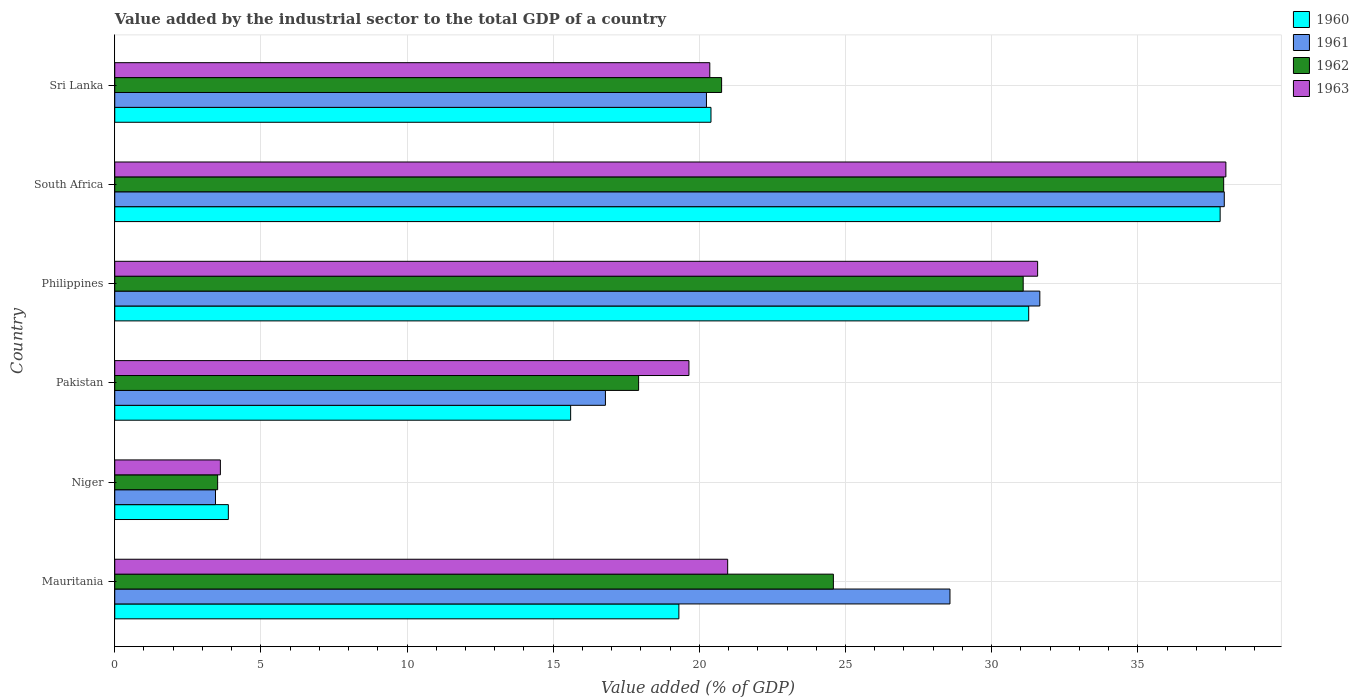Are the number of bars per tick equal to the number of legend labels?
Your response must be concise. Yes. Are the number of bars on each tick of the Y-axis equal?
Provide a succinct answer. Yes. How many bars are there on the 6th tick from the top?
Offer a very short reply. 4. How many bars are there on the 3rd tick from the bottom?
Keep it short and to the point. 4. What is the label of the 5th group of bars from the top?
Your answer should be very brief. Niger. In how many cases, is the number of bars for a given country not equal to the number of legend labels?
Your answer should be compact. 0. What is the value added by the industrial sector to the total GDP in 1963 in Niger?
Your answer should be compact. 3.61. Across all countries, what is the maximum value added by the industrial sector to the total GDP in 1963?
Your answer should be compact. 38.01. Across all countries, what is the minimum value added by the industrial sector to the total GDP in 1963?
Offer a very short reply. 3.61. In which country was the value added by the industrial sector to the total GDP in 1961 maximum?
Offer a terse response. South Africa. In which country was the value added by the industrial sector to the total GDP in 1961 minimum?
Offer a terse response. Niger. What is the total value added by the industrial sector to the total GDP in 1961 in the graph?
Ensure brevity in your answer.  138.66. What is the difference between the value added by the industrial sector to the total GDP in 1960 in Mauritania and that in Sri Lanka?
Provide a short and direct response. -1.1. What is the difference between the value added by the industrial sector to the total GDP in 1961 in Mauritania and the value added by the industrial sector to the total GDP in 1960 in South Africa?
Ensure brevity in your answer.  -9.24. What is the average value added by the industrial sector to the total GDP in 1963 per country?
Make the answer very short. 22.36. What is the difference between the value added by the industrial sector to the total GDP in 1961 and value added by the industrial sector to the total GDP in 1962 in Mauritania?
Offer a very short reply. 3.99. In how many countries, is the value added by the industrial sector to the total GDP in 1963 greater than 27 %?
Your answer should be very brief. 2. What is the ratio of the value added by the industrial sector to the total GDP in 1960 in Pakistan to that in South Africa?
Your answer should be very brief. 0.41. What is the difference between the highest and the second highest value added by the industrial sector to the total GDP in 1963?
Your response must be concise. 6.44. What is the difference between the highest and the lowest value added by the industrial sector to the total GDP in 1963?
Ensure brevity in your answer.  34.4. What does the 2nd bar from the top in Mauritania represents?
Your answer should be compact. 1962. Is it the case that in every country, the sum of the value added by the industrial sector to the total GDP in 1960 and value added by the industrial sector to the total GDP in 1963 is greater than the value added by the industrial sector to the total GDP in 1961?
Your answer should be compact. Yes. How many bars are there?
Your answer should be compact. 24. How many countries are there in the graph?
Provide a short and direct response. 6. Are the values on the major ticks of X-axis written in scientific E-notation?
Ensure brevity in your answer.  No. Where does the legend appear in the graph?
Provide a short and direct response. Top right. How are the legend labels stacked?
Offer a very short reply. Vertical. What is the title of the graph?
Your answer should be compact. Value added by the industrial sector to the total GDP of a country. Does "1978" appear as one of the legend labels in the graph?
Your response must be concise. No. What is the label or title of the X-axis?
Offer a very short reply. Value added (% of GDP). What is the Value added (% of GDP) of 1960 in Mauritania?
Offer a terse response. 19.3. What is the Value added (% of GDP) in 1961 in Mauritania?
Give a very brief answer. 28.57. What is the Value added (% of GDP) of 1962 in Mauritania?
Provide a succinct answer. 24.59. What is the Value added (% of GDP) in 1963 in Mauritania?
Your response must be concise. 20.97. What is the Value added (% of GDP) in 1960 in Niger?
Your answer should be compact. 3.89. What is the Value added (% of GDP) of 1961 in Niger?
Your answer should be compact. 3.45. What is the Value added (% of GDP) of 1962 in Niger?
Offer a very short reply. 3.52. What is the Value added (% of GDP) of 1963 in Niger?
Offer a very short reply. 3.61. What is the Value added (% of GDP) in 1960 in Pakistan?
Offer a terse response. 15.6. What is the Value added (% of GDP) of 1961 in Pakistan?
Give a very brief answer. 16.79. What is the Value added (% of GDP) of 1962 in Pakistan?
Your response must be concise. 17.92. What is the Value added (% of GDP) of 1963 in Pakistan?
Offer a terse response. 19.64. What is the Value added (% of GDP) in 1960 in Philippines?
Keep it short and to the point. 31.27. What is the Value added (% of GDP) of 1961 in Philippines?
Offer a terse response. 31.65. What is the Value added (% of GDP) in 1962 in Philippines?
Make the answer very short. 31.08. What is the Value added (% of GDP) of 1963 in Philippines?
Your response must be concise. 31.57. What is the Value added (% of GDP) of 1960 in South Africa?
Offer a terse response. 37.82. What is the Value added (% of GDP) in 1961 in South Africa?
Your response must be concise. 37.96. What is the Value added (% of GDP) of 1962 in South Africa?
Offer a very short reply. 37.94. What is the Value added (% of GDP) of 1963 in South Africa?
Give a very brief answer. 38.01. What is the Value added (% of GDP) in 1960 in Sri Lanka?
Ensure brevity in your answer.  20.4. What is the Value added (% of GDP) of 1961 in Sri Lanka?
Your answer should be very brief. 20.24. What is the Value added (% of GDP) in 1962 in Sri Lanka?
Your answer should be very brief. 20.76. What is the Value added (% of GDP) of 1963 in Sri Lanka?
Keep it short and to the point. 20.36. Across all countries, what is the maximum Value added (% of GDP) of 1960?
Provide a short and direct response. 37.82. Across all countries, what is the maximum Value added (% of GDP) in 1961?
Your answer should be very brief. 37.96. Across all countries, what is the maximum Value added (% of GDP) in 1962?
Ensure brevity in your answer.  37.94. Across all countries, what is the maximum Value added (% of GDP) in 1963?
Offer a very short reply. 38.01. Across all countries, what is the minimum Value added (% of GDP) of 1960?
Make the answer very short. 3.89. Across all countries, what is the minimum Value added (% of GDP) of 1961?
Offer a terse response. 3.45. Across all countries, what is the minimum Value added (% of GDP) of 1962?
Make the answer very short. 3.52. Across all countries, what is the minimum Value added (% of GDP) in 1963?
Provide a short and direct response. 3.61. What is the total Value added (% of GDP) in 1960 in the graph?
Give a very brief answer. 128.27. What is the total Value added (% of GDP) of 1961 in the graph?
Keep it short and to the point. 138.66. What is the total Value added (% of GDP) of 1962 in the graph?
Offer a very short reply. 135.81. What is the total Value added (% of GDP) in 1963 in the graph?
Keep it short and to the point. 134.17. What is the difference between the Value added (% of GDP) in 1960 in Mauritania and that in Niger?
Ensure brevity in your answer.  15.41. What is the difference between the Value added (% of GDP) in 1961 in Mauritania and that in Niger?
Offer a very short reply. 25.13. What is the difference between the Value added (% of GDP) in 1962 in Mauritania and that in Niger?
Your answer should be very brief. 21.07. What is the difference between the Value added (% of GDP) in 1963 in Mauritania and that in Niger?
Ensure brevity in your answer.  17.36. What is the difference between the Value added (% of GDP) in 1960 in Mauritania and that in Pakistan?
Provide a short and direct response. 3.7. What is the difference between the Value added (% of GDP) in 1961 in Mauritania and that in Pakistan?
Your answer should be very brief. 11.79. What is the difference between the Value added (% of GDP) in 1962 in Mauritania and that in Pakistan?
Ensure brevity in your answer.  6.66. What is the difference between the Value added (% of GDP) in 1963 in Mauritania and that in Pakistan?
Provide a succinct answer. 1.33. What is the difference between the Value added (% of GDP) of 1960 in Mauritania and that in Philippines?
Your answer should be very brief. -11.97. What is the difference between the Value added (% of GDP) of 1961 in Mauritania and that in Philippines?
Provide a succinct answer. -3.07. What is the difference between the Value added (% of GDP) of 1962 in Mauritania and that in Philippines?
Your answer should be very brief. -6.49. What is the difference between the Value added (% of GDP) in 1963 in Mauritania and that in Philippines?
Offer a terse response. -10.6. What is the difference between the Value added (% of GDP) in 1960 in Mauritania and that in South Africa?
Your answer should be compact. -18.52. What is the difference between the Value added (% of GDP) of 1961 in Mauritania and that in South Africa?
Ensure brevity in your answer.  -9.38. What is the difference between the Value added (% of GDP) of 1962 in Mauritania and that in South Africa?
Offer a terse response. -13.35. What is the difference between the Value added (% of GDP) in 1963 in Mauritania and that in South Africa?
Your answer should be very brief. -17.04. What is the difference between the Value added (% of GDP) of 1960 in Mauritania and that in Sri Lanka?
Your response must be concise. -1.1. What is the difference between the Value added (% of GDP) in 1961 in Mauritania and that in Sri Lanka?
Make the answer very short. 8.33. What is the difference between the Value added (% of GDP) in 1962 in Mauritania and that in Sri Lanka?
Offer a very short reply. 3.82. What is the difference between the Value added (% of GDP) in 1963 in Mauritania and that in Sri Lanka?
Make the answer very short. 0.61. What is the difference between the Value added (% of GDP) of 1960 in Niger and that in Pakistan?
Offer a terse response. -11.71. What is the difference between the Value added (% of GDP) of 1961 in Niger and that in Pakistan?
Offer a very short reply. -13.34. What is the difference between the Value added (% of GDP) of 1962 in Niger and that in Pakistan?
Keep it short and to the point. -14.4. What is the difference between the Value added (% of GDP) in 1963 in Niger and that in Pakistan?
Offer a very short reply. -16.03. What is the difference between the Value added (% of GDP) of 1960 in Niger and that in Philippines?
Offer a terse response. -27.38. What is the difference between the Value added (% of GDP) of 1961 in Niger and that in Philippines?
Your answer should be very brief. -28.2. What is the difference between the Value added (% of GDP) in 1962 in Niger and that in Philippines?
Your response must be concise. -27.56. What is the difference between the Value added (% of GDP) in 1963 in Niger and that in Philippines?
Ensure brevity in your answer.  -27.96. What is the difference between the Value added (% of GDP) of 1960 in Niger and that in South Africa?
Your answer should be very brief. -33.93. What is the difference between the Value added (% of GDP) of 1961 in Niger and that in South Africa?
Provide a short and direct response. -34.51. What is the difference between the Value added (% of GDP) of 1962 in Niger and that in South Africa?
Keep it short and to the point. -34.42. What is the difference between the Value added (% of GDP) of 1963 in Niger and that in South Africa?
Your answer should be very brief. -34.4. What is the difference between the Value added (% of GDP) in 1960 in Niger and that in Sri Lanka?
Your response must be concise. -16.51. What is the difference between the Value added (% of GDP) of 1961 in Niger and that in Sri Lanka?
Ensure brevity in your answer.  -16.8. What is the difference between the Value added (% of GDP) in 1962 in Niger and that in Sri Lanka?
Provide a succinct answer. -17.24. What is the difference between the Value added (% of GDP) in 1963 in Niger and that in Sri Lanka?
Offer a very short reply. -16.74. What is the difference between the Value added (% of GDP) of 1960 in Pakistan and that in Philippines?
Your response must be concise. -15.67. What is the difference between the Value added (% of GDP) of 1961 in Pakistan and that in Philippines?
Your answer should be very brief. -14.86. What is the difference between the Value added (% of GDP) in 1962 in Pakistan and that in Philippines?
Give a very brief answer. -13.16. What is the difference between the Value added (% of GDP) in 1963 in Pakistan and that in Philippines?
Offer a terse response. -11.93. What is the difference between the Value added (% of GDP) of 1960 in Pakistan and that in South Africa?
Ensure brevity in your answer.  -22.22. What is the difference between the Value added (% of GDP) of 1961 in Pakistan and that in South Africa?
Give a very brief answer. -21.17. What is the difference between the Value added (% of GDP) in 1962 in Pakistan and that in South Africa?
Offer a very short reply. -20.02. What is the difference between the Value added (% of GDP) of 1963 in Pakistan and that in South Africa?
Your response must be concise. -18.37. What is the difference between the Value added (% of GDP) in 1960 in Pakistan and that in Sri Lanka?
Provide a short and direct response. -4.8. What is the difference between the Value added (% of GDP) in 1961 in Pakistan and that in Sri Lanka?
Keep it short and to the point. -3.46. What is the difference between the Value added (% of GDP) of 1962 in Pakistan and that in Sri Lanka?
Provide a short and direct response. -2.84. What is the difference between the Value added (% of GDP) of 1963 in Pakistan and that in Sri Lanka?
Provide a succinct answer. -0.71. What is the difference between the Value added (% of GDP) of 1960 in Philippines and that in South Africa?
Offer a terse response. -6.55. What is the difference between the Value added (% of GDP) of 1961 in Philippines and that in South Africa?
Your response must be concise. -6.31. What is the difference between the Value added (% of GDP) in 1962 in Philippines and that in South Africa?
Your answer should be very brief. -6.86. What is the difference between the Value added (% of GDP) of 1963 in Philippines and that in South Africa?
Your response must be concise. -6.44. What is the difference between the Value added (% of GDP) of 1960 in Philippines and that in Sri Lanka?
Make the answer very short. 10.87. What is the difference between the Value added (% of GDP) in 1961 in Philippines and that in Sri Lanka?
Your answer should be compact. 11.41. What is the difference between the Value added (% of GDP) in 1962 in Philippines and that in Sri Lanka?
Provide a succinct answer. 10.32. What is the difference between the Value added (% of GDP) in 1963 in Philippines and that in Sri Lanka?
Ensure brevity in your answer.  11.22. What is the difference between the Value added (% of GDP) in 1960 in South Africa and that in Sri Lanka?
Your response must be concise. 17.42. What is the difference between the Value added (% of GDP) of 1961 in South Africa and that in Sri Lanka?
Offer a terse response. 17.72. What is the difference between the Value added (% of GDP) in 1962 in South Africa and that in Sri Lanka?
Your answer should be very brief. 17.18. What is the difference between the Value added (% of GDP) of 1963 in South Africa and that in Sri Lanka?
Keep it short and to the point. 17.66. What is the difference between the Value added (% of GDP) of 1960 in Mauritania and the Value added (% of GDP) of 1961 in Niger?
Give a very brief answer. 15.85. What is the difference between the Value added (% of GDP) of 1960 in Mauritania and the Value added (% of GDP) of 1962 in Niger?
Your response must be concise. 15.78. What is the difference between the Value added (% of GDP) of 1960 in Mauritania and the Value added (% of GDP) of 1963 in Niger?
Make the answer very short. 15.69. What is the difference between the Value added (% of GDP) in 1961 in Mauritania and the Value added (% of GDP) in 1962 in Niger?
Keep it short and to the point. 25.05. What is the difference between the Value added (% of GDP) of 1961 in Mauritania and the Value added (% of GDP) of 1963 in Niger?
Give a very brief answer. 24.96. What is the difference between the Value added (% of GDP) of 1962 in Mauritania and the Value added (% of GDP) of 1963 in Niger?
Give a very brief answer. 20.97. What is the difference between the Value added (% of GDP) in 1960 in Mauritania and the Value added (% of GDP) in 1961 in Pakistan?
Provide a short and direct response. 2.51. What is the difference between the Value added (% of GDP) of 1960 in Mauritania and the Value added (% of GDP) of 1962 in Pakistan?
Keep it short and to the point. 1.38. What is the difference between the Value added (% of GDP) of 1960 in Mauritania and the Value added (% of GDP) of 1963 in Pakistan?
Keep it short and to the point. -0.34. What is the difference between the Value added (% of GDP) in 1961 in Mauritania and the Value added (% of GDP) in 1962 in Pakistan?
Offer a very short reply. 10.65. What is the difference between the Value added (% of GDP) of 1961 in Mauritania and the Value added (% of GDP) of 1963 in Pakistan?
Keep it short and to the point. 8.93. What is the difference between the Value added (% of GDP) of 1962 in Mauritania and the Value added (% of GDP) of 1963 in Pakistan?
Offer a very short reply. 4.94. What is the difference between the Value added (% of GDP) of 1960 in Mauritania and the Value added (% of GDP) of 1961 in Philippines?
Keep it short and to the point. -12.35. What is the difference between the Value added (% of GDP) in 1960 in Mauritania and the Value added (% of GDP) in 1962 in Philippines?
Your response must be concise. -11.78. What is the difference between the Value added (% of GDP) of 1960 in Mauritania and the Value added (% of GDP) of 1963 in Philippines?
Keep it short and to the point. -12.27. What is the difference between the Value added (% of GDP) of 1961 in Mauritania and the Value added (% of GDP) of 1962 in Philippines?
Give a very brief answer. -2.51. What is the difference between the Value added (% of GDP) in 1961 in Mauritania and the Value added (% of GDP) in 1963 in Philippines?
Give a very brief answer. -3. What is the difference between the Value added (% of GDP) in 1962 in Mauritania and the Value added (% of GDP) in 1963 in Philippines?
Offer a terse response. -6.99. What is the difference between the Value added (% of GDP) of 1960 in Mauritania and the Value added (% of GDP) of 1961 in South Africa?
Make the answer very short. -18.66. What is the difference between the Value added (% of GDP) in 1960 in Mauritania and the Value added (% of GDP) in 1962 in South Africa?
Offer a terse response. -18.64. What is the difference between the Value added (% of GDP) of 1960 in Mauritania and the Value added (% of GDP) of 1963 in South Africa?
Keep it short and to the point. -18.71. What is the difference between the Value added (% of GDP) of 1961 in Mauritania and the Value added (% of GDP) of 1962 in South Africa?
Keep it short and to the point. -9.36. What is the difference between the Value added (% of GDP) of 1961 in Mauritania and the Value added (% of GDP) of 1963 in South Africa?
Provide a succinct answer. -9.44. What is the difference between the Value added (% of GDP) of 1962 in Mauritania and the Value added (% of GDP) of 1963 in South Africa?
Provide a succinct answer. -13.43. What is the difference between the Value added (% of GDP) in 1960 in Mauritania and the Value added (% of GDP) in 1961 in Sri Lanka?
Your response must be concise. -0.94. What is the difference between the Value added (% of GDP) of 1960 in Mauritania and the Value added (% of GDP) of 1962 in Sri Lanka?
Provide a succinct answer. -1.46. What is the difference between the Value added (% of GDP) of 1960 in Mauritania and the Value added (% of GDP) of 1963 in Sri Lanka?
Provide a short and direct response. -1.06. What is the difference between the Value added (% of GDP) of 1961 in Mauritania and the Value added (% of GDP) of 1962 in Sri Lanka?
Provide a short and direct response. 7.81. What is the difference between the Value added (% of GDP) in 1961 in Mauritania and the Value added (% of GDP) in 1963 in Sri Lanka?
Provide a succinct answer. 8.22. What is the difference between the Value added (% of GDP) in 1962 in Mauritania and the Value added (% of GDP) in 1963 in Sri Lanka?
Offer a terse response. 4.23. What is the difference between the Value added (% of GDP) in 1960 in Niger and the Value added (% of GDP) in 1961 in Pakistan?
Give a very brief answer. -12.9. What is the difference between the Value added (% of GDP) of 1960 in Niger and the Value added (% of GDP) of 1962 in Pakistan?
Offer a very short reply. -14.04. What is the difference between the Value added (% of GDP) of 1960 in Niger and the Value added (% of GDP) of 1963 in Pakistan?
Provide a short and direct response. -15.76. What is the difference between the Value added (% of GDP) of 1961 in Niger and the Value added (% of GDP) of 1962 in Pakistan?
Ensure brevity in your answer.  -14.48. What is the difference between the Value added (% of GDP) of 1961 in Niger and the Value added (% of GDP) of 1963 in Pakistan?
Offer a very short reply. -16.2. What is the difference between the Value added (% of GDP) of 1962 in Niger and the Value added (% of GDP) of 1963 in Pakistan?
Provide a short and direct response. -16.12. What is the difference between the Value added (% of GDP) in 1960 in Niger and the Value added (% of GDP) in 1961 in Philippines?
Your answer should be compact. -27.76. What is the difference between the Value added (% of GDP) in 1960 in Niger and the Value added (% of GDP) in 1962 in Philippines?
Provide a short and direct response. -27.19. What is the difference between the Value added (% of GDP) in 1960 in Niger and the Value added (% of GDP) in 1963 in Philippines?
Provide a short and direct response. -27.69. What is the difference between the Value added (% of GDP) in 1961 in Niger and the Value added (% of GDP) in 1962 in Philippines?
Ensure brevity in your answer.  -27.63. What is the difference between the Value added (% of GDP) in 1961 in Niger and the Value added (% of GDP) in 1963 in Philippines?
Ensure brevity in your answer.  -28.13. What is the difference between the Value added (% of GDP) of 1962 in Niger and the Value added (% of GDP) of 1963 in Philippines?
Your answer should be very brief. -28.05. What is the difference between the Value added (% of GDP) of 1960 in Niger and the Value added (% of GDP) of 1961 in South Africa?
Your response must be concise. -34.07. What is the difference between the Value added (% of GDP) in 1960 in Niger and the Value added (% of GDP) in 1962 in South Africa?
Give a very brief answer. -34.05. What is the difference between the Value added (% of GDP) of 1960 in Niger and the Value added (% of GDP) of 1963 in South Africa?
Your answer should be compact. -34.13. What is the difference between the Value added (% of GDP) of 1961 in Niger and the Value added (% of GDP) of 1962 in South Africa?
Offer a very short reply. -34.49. What is the difference between the Value added (% of GDP) of 1961 in Niger and the Value added (% of GDP) of 1963 in South Africa?
Keep it short and to the point. -34.57. What is the difference between the Value added (% of GDP) in 1962 in Niger and the Value added (% of GDP) in 1963 in South Africa?
Keep it short and to the point. -34.49. What is the difference between the Value added (% of GDP) in 1960 in Niger and the Value added (% of GDP) in 1961 in Sri Lanka?
Keep it short and to the point. -16.36. What is the difference between the Value added (% of GDP) of 1960 in Niger and the Value added (% of GDP) of 1962 in Sri Lanka?
Offer a terse response. -16.88. What is the difference between the Value added (% of GDP) of 1960 in Niger and the Value added (% of GDP) of 1963 in Sri Lanka?
Ensure brevity in your answer.  -16.47. What is the difference between the Value added (% of GDP) in 1961 in Niger and the Value added (% of GDP) in 1962 in Sri Lanka?
Your answer should be compact. -17.32. What is the difference between the Value added (% of GDP) of 1961 in Niger and the Value added (% of GDP) of 1963 in Sri Lanka?
Offer a very short reply. -16.91. What is the difference between the Value added (% of GDP) of 1962 in Niger and the Value added (% of GDP) of 1963 in Sri Lanka?
Ensure brevity in your answer.  -16.84. What is the difference between the Value added (% of GDP) in 1960 in Pakistan and the Value added (% of GDP) in 1961 in Philippines?
Keep it short and to the point. -16.05. What is the difference between the Value added (% of GDP) of 1960 in Pakistan and the Value added (% of GDP) of 1962 in Philippines?
Give a very brief answer. -15.48. What is the difference between the Value added (% of GDP) of 1960 in Pakistan and the Value added (% of GDP) of 1963 in Philippines?
Your response must be concise. -15.98. What is the difference between the Value added (% of GDP) in 1961 in Pakistan and the Value added (% of GDP) in 1962 in Philippines?
Offer a terse response. -14.29. What is the difference between the Value added (% of GDP) in 1961 in Pakistan and the Value added (% of GDP) in 1963 in Philippines?
Ensure brevity in your answer.  -14.79. What is the difference between the Value added (% of GDP) of 1962 in Pakistan and the Value added (% of GDP) of 1963 in Philippines?
Offer a terse response. -13.65. What is the difference between the Value added (% of GDP) of 1960 in Pakistan and the Value added (% of GDP) of 1961 in South Africa?
Your answer should be very brief. -22.36. What is the difference between the Value added (% of GDP) of 1960 in Pakistan and the Value added (% of GDP) of 1962 in South Africa?
Provide a short and direct response. -22.34. What is the difference between the Value added (% of GDP) of 1960 in Pakistan and the Value added (% of GDP) of 1963 in South Africa?
Your answer should be very brief. -22.42. What is the difference between the Value added (% of GDP) in 1961 in Pakistan and the Value added (% of GDP) in 1962 in South Africa?
Your response must be concise. -21.15. What is the difference between the Value added (% of GDP) of 1961 in Pakistan and the Value added (% of GDP) of 1963 in South Africa?
Your response must be concise. -21.23. What is the difference between the Value added (% of GDP) in 1962 in Pakistan and the Value added (% of GDP) in 1963 in South Africa?
Provide a short and direct response. -20.09. What is the difference between the Value added (% of GDP) in 1960 in Pakistan and the Value added (% of GDP) in 1961 in Sri Lanka?
Your answer should be compact. -4.65. What is the difference between the Value added (% of GDP) in 1960 in Pakistan and the Value added (% of GDP) in 1962 in Sri Lanka?
Your response must be concise. -5.16. What is the difference between the Value added (% of GDP) in 1960 in Pakistan and the Value added (% of GDP) in 1963 in Sri Lanka?
Your answer should be compact. -4.76. What is the difference between the Value added (% of GDP) in 1961 in Pakistan and the Value added (% of GDP) in 1962 in Sri Lanka?
Your response must be concise. -3.97. What is the difference between the Value added (% of GDP) in 1961 in Pakistan and the Value added (% of GDP) in 1963 in Sri Lanka?
Offer a terse response. -3.57. What is the difference between the Value added (% of GDP) of 1962 in Pakistan and the Value added (% of GDP) of 1963 in Sri Lanka?
Offer a very short reply. -2.44. What is the difference between the Value added (% of GDP) of 1960 in Philippines and the Value added (% of GDP) of 1961 in South Africa?
Make the answer very short. -6.69. What is the difference between the Value added (% of GDP) in 1960 in Philippines and the Value added (% of GDP) in 1962 in South Africa?
Your response must be concise. -6.67. What is the difference between the Value added (% of GDP) in 1960 in Philippines and the Value added (% of GDP) in 1963 in South Africa?
Ensure brevity in your answer.  -6.75. What is the difference between the Value added (% of GDP) of 1961 in Philippines and the Value added (% of GDP) of 1962 in South Africa?
Offer a terse response. -6.29. What is the difference between the Value added (% of GDP) in 1961 in Philippines and the Value added (% of GDP) in 1963 in South Africa?
Give a very brief answer. -6.37. What is the difference between the Value added (% of GDP) of 1962 in Philippines and the Value added (% of GDP) of 1963 in South Africa?
Give a very brief answer. -6.93. What is the difference between the Value added (% of GDP) in 1960 in Philippines and the Value added (% of GDP) in 1961 in Sri Lanka?
Offer a terse response. 11.03. What is the difference between the Value added (% of GDP) of 1960 in Philippines and the Value added (% of GDP) of 1962 in Sri Lanka?
Offer a terse response. 10.51. What is the difference between the Value added (% of GDP) in 1960 in Philippines and the Value added (% of GDP) in 1963 in Sri Lanka?
Your answer should be very brief. 10.91. What is the difference between the Value added (% of GDP) of 1961 in Philippines and the Value added (% of GDP) of 1962 in Sri Lanka?
Offer a very short reply. 10.89. What is the difference between the Value added (% of GDP) of 1961 in Philippines and the Value added (% of GDP) of 1963 in Sri Lanka?
Your answer should be very brief. 11.29. What is the difference between the Value added (% of GDP) of 1962 in Philippines and the Value added (% of GDP) of 1963 in Sri Lanka?
Make the answer very short. 10.72. What is the difference between the Value added (% of GDP) in 1960 in South Africa and the Value added (% of GDP) in 1961 in Sri Lanka?
Provide a short and direct response. 17.57. What is the difference between the Value added (% of GDP) in 1960 in South Africa and the Value added (% of GDP) in 1962 in Sri Lanka?
Provide a short and direct response. 17.06. What is the difference between the Value added (% of GDP) in 1960 in South Africa and the Value added (% of GDP) in 1963 in Sri Lanka?
Ensure brevity in your answer.  17.46. What is the difference between the Value added (% of GDP) in 1961 in South Africa and the Value added (% of GDP) in 1962 in Sri Lanka?
Make the answer very short. 17.2. What is the difference between the Value added (% of GDP) of 1961 in South Africa and the Value added (% of GDP) of 1963 in Sri Lanka?
Your answer should be very brief. 17.6. What is the difference between the Value added (% of GDP) in 1962 in South Africa and the Value added (% of GDP) in 1963 in Sri Lanka?
Your answer should be very brief. 17.58. What is the average Value added (% of GDP) in 1960 per country?
Ensure brevity in your answer.  21.38. What is the average Value added (% of GDP) of 1961 per country?
Provide a succinct answer. 23.11. What is the average Value added (% of GDP) in 1962 per country?
Your answer should be very brief. 22.63. What is the average Value added (% of GDP) of 1963 per country?
Ensure brevity in your answer.  22.36. What is the difference between the Value added (% of GDP) of 1960 and Value added (% of GDP) of 1961 in Mauritania?
Make the answer very short. -9.27. What is the difference between the Value added (% of GDP) in 1960 and Value added (% of GDP) in 1962 in Mauritania?
Your response must be concise. -5.29. What is the difference between the Value added (% of GDP) of 1960 and Value added (% of GDP) of 1963 in Mauritania?
Offer a very short reply. -1.67. What is the difference between the Value added (% of GDP) of 1961 and Value added (% of GDP) of 1962 in Mauritania?
Keep it short and to the point. 3.99. What is the difference between the Value added (% of GDP) of 1961 and Value added (% of GDP) of 1963 in Mauritania?
Offer a very short reply. 7.6. What is the difference between the Value added (% of GDP) in 1962 and Value added (% of GDP) in 1963 in Mauritania?
Offer a very short reply. 3.62. What is the difference between the Value added (% of GDP) in 1960 and Value added (% of GDP) in 1961 in Niger?
Make the answer very short. 0.44. What is the difference between the Value added (% of GDP) of 1960 and Value added (% of GDP) of 1962 in Niger?
Provide a succinct answer. 0.37. What is the difference between the Value added (% of GDP) in 1960 and Value added (% of GDP) in 1963 in Niger?
Provide a short and direct response. 0.27. What is the difference between the Value added (% of GDP) in 1961 and Value added (% of GDP) in 1962 in Niger?
Keep it short and to the point. -0.07. What is the difference between the Value added (% of GDP) of 1961 and Value added (% of GDP) of 1963 in Niger?
Make the answer very short. -0.17. What is the difference between the Value added (% of GDP) in 1962 and Value added (% of GDP) in 1963 in Niger?
Ensure brevity in your answer.  -0.09. What is the difference between the Value added (% of GDP) of 1960 and Value added (% of GDP) of 1961 in Pakistan?
Your response must be concise. -1.19. What is the difference between the Value added (% of GDP) of 1960 and Value added (% of GDP) of 1962 in Pakistan?
Your response must be concise. -2.33. What is the difference between the Value added (% of GDP) of 1960 and Value added (% of GDP) of 1963 in Pakistan?
Your answer should be very brief. -4.05. What is the difference between the Value added (% of GDP) of 1961 and Value added (% of GDP) of 1962 in Pakistan?
Keep it short and to the point. -1.14. What is the difference between the Value added (% of GDP) of 1961 and Value added (% of GDP) of 1963 in Pakistan?
Offer a very short reply. -2.86. What is the difference between the Value added (% of GDP) in 1962 and Value added (% of GDP) in 1963 in Pakistan?
Make the answer very short. -1.72. What is the difference between the Value added (% of GDP) in 1960 and Value added (% of GDP) in 1961 in Philippines?
Give a very brief answer. -0.38. What is the difference between the Value added (% of GDP) in 1960 and Value added (% of GDP) in 1962 in Philippines?
Offer a very short reply. 0.19. What is the difference between the Value added (% of GDP) in 1960 and Value added (% of GDP) in 1963 in Philippines?
Keep it short and to the point. -0.3. What is the difference between the Value added (% of GDP) of 1961 and Value added (% of GDP) of 1962 in Philippines?
Your answer should be very brief. 0.57. What is the difference between the Value added (% of GDP) in 1961 and Value added (% of GDP) in 1963 in Philippines?
Provide a succinct answer. 0.08. What is the difference between the Value added (% of GDP) of 1962 and Value added (% of GDP) of 1963 in Philippines?
Provide a succinct answer. -0.49. What is the difference between the Value added (% of GDP) of 1960 and Value added (% of GDP) of 1961 in South Africa?
Ensure brevity in your answer.  -0.14. What is the difference between the Value added (% of GDP) in 1960 and Value added (% of GDP) in 1962 in South Africa?
Give a very brief answer. -0.12. What is the difference between the Value added (% of GDP) in 1960 and Value added (% of GDP) in 1963 in South Africa?
Make the answer very short. -0.2. What is the difference between the Value added (% of GDP) of 1961 and Value added (% of GDP) of 1962 in South Africa?
Make the answer very short. 0.02. What is the difference between the Value added (% of GDP) in 1961 and Value added (% of GDP) in 1963 in South Africa?
Your answer should be compact. -0.05. What is the difference between the Value added (% of GDP) in 1962 and Value added (% of GDP) in 1963 in South Africa?
Keep it short and to the point. -0.08. What is the difference between the Value added (% of GDP) in 1960 and Value added (% of GDP) in 1961 in Sri Lanka?
Provide a short and direct response. 0.16. What is the difference between the Value added (% of GDP) in 1960 and Value added (% of GDP) in 1962 in Sri Lanka?
Provide a succinct answer. -0.36. What is the difference between the Value added (% of GDP) of 1960 and Value added (% of GDP) of 1963 in Sri Lanka?
Provide a succinct answer. 0.04. What is the difference between the Value added (% of GDP) of 1961 and Value added (% of GDP) of 1962 in Sri Lanka?
Give a very brief answer. -0.52. What is the difference between the Value added (% of GDP) in 1961 and Value added (% of GDP) in 1963 in Sri Lanka?
Keep it short and to the point. -0.11. What is the difference between the Value added (% of GDP) of 1962 and Value added (% of GDP) of 1963 in Sri Lanka?
Keep it short and to the point. 0.4. What is the ratio of the Value added (% of GDP) in 1960 in Mauritania to that in Niger?
Your answer should be compact. 4.97. What is the ratio of the Value added (% of GDP) in 1961 in Mauritania to that in Niger?
Provide a short and direct response. 8.29. What is the ratio of the Value added (% of GDP) in 1962 in Mauritania to that in Niger?
Provide a short and direct response. 6.99. What is the ratio of the Value added (% of GDP) in 1963 in Mauritania to that in Niger?
Your answer should be compact. 5.8. What is the ratio of the Value added (% of GDP) in 1960 in Mauritania to that in Pakistan?
Your answer should be compact. 1.24. What is the ratio of the Value added (% of GDP) in 1961 in Mauritania to that in Pakistan?
Provide a succinct answer. 1.7. What is the ratio of the Value added (% of GDP) of 1962 in Mauritania to that in Pakistan?
Give a very brief answer. 1.37. What is the ratio of the Value added (% of GDP) in 1963 in Mauritania to that in Pakistan?
Provide a succinct answer. 1.07. What is the ratio of the Value added (% of GDP) of 1960 in Mauritania to that in Philippines?
Give a very brief answer. 0.62. What is the ratio of the Value added (% of GDP) in 1961 in Mauritania to that in Philippines?
Your answer should be compact. 0.9. What is the ratio of the Value added (% of GDP) of 1962 in Mauritania to that in Philippines?
Make the answer very short. 0.79. What is the ratio of the Value added (% of GDP) in 1963 in Mauritania to that in Philippines?
Your answer should be very brief. 0.66. What is the ratio of the Value added (% of GDP) in 1960 in Mauritania to that in South Africa?
Make the answer very short. 0.51. What is the ratio of the Value added (% of GDP) in 1961 in Mauritania to that in South Africa?
Provide a short and direct response. 0.75. What is the ratio of the Value added (% of GDP) in 1962 in Mauritania to that in South Africa?
Ensure brevity in your answer.  0.65. What is the ratio of the Value added (% of GDP) of 1963 in Mauritania to that in South Africa?
Your response must be concise. 0.55. What is the ratio of the Value added (% of GDP) in 1960 in Mauritania to that in Sri Lanka?
Offer a terse response. 0.95. What is the ratio of the Value added (% of GDP) in 1961 in Mauritania to that in Sri Lanka?
Provide a succinct answer. 1.41. What is the ratio of the Value added (% of GDP) of 1962 in Mauritania to that in Sri Lanka?
Offer a very short reply. 1.18. What is the ratio of the Value added (% of GDP) in 1960 in Niger to that in Pakistan?
Make the answer very short. 0.25. What is the ratio of the Value added (% of GDP) of 1961 in Niger to that in Pakistan?
Your answer should be very brief. 0.21. What is the ratio of the Value added (% of GDP) of 1962 in Niger to that in Pakistan?
Provide a succinct answer. 0.2. What is the ratio of the Value added (% of GDP) of 1963 in Niger to that in Pakistan?
Your answer should be very brief. 0.18. What is the ratio of the Value added (% of GDP) of 1960 in Niger to that in Philippines?
Your answer should be very brief. 0.12. What is the ratio of the Value added (% of GDP) of 1961 in Niger to that in Philippines?
Ensure brevity in your answer.  0.11. What is the ratio of the Value added (% of GDP) in 1962 in Niger to that in Philippines?
Offer a very short reply. 0.11. What is the ratio of the Value added (% of GDP) in 1963 in Niger to that in Philippines?
Your answer should be compact. 0.11. What is the ratio of the Value added (% of GDP) in 1960 in Niger to that in South Africa?
Your answer should be very brief. 0.1. What is the ratio of the Value added (% of GDP) in 1961 in Niger to that in South Africa?
Keep it short and to the point. 0.09. What is the ratio of the Value added (% of GDP) in 1962 in Niger to that in South Africa?
Ensure brevity in your answer.  0.09. What is the ratio of the Value added (% of GDP) in 1963 in Niger to that in South Africa?
Provide a succinct answer. 0.1. What is the ratio of the Value added (% of GDP) in 1960 in Niger to that in Sri Lanka?
Give a very brief answer. 0.19. What is the ratio of the Value added (% of GDP) of 1961 in Niger to that in Sri Lanka?
Provide a succinct answer. 0.17. What is the ratio of the Value added (% of GDP) in 1962 in Niger to that in Sri Lanka?
Your answer should be compact. 0.17. What is the ratio of the Value added (% of GDP) in 1963 in Niger to that in Sri Lanka?
Ensure brevity in your answer.  0.18. What is the ratio of the Value added (% of GDP) of 1960 in Pakistan to that in Philippines?
Your answer should be compact. 0.5. What is the ratio of the Value added (% of GDP) in 1961 in Pakistan to that in Philippines?
Provide a succinct answer. 0.53. What is the ratio of the Value added (% of GDP) in 1962 in Pakistan to that in Philippines?
Give a very brief answer. 0.58. What is the ratio of the Value added (% of GDP) of 1963 in Pakistan to that in Philippines?
Your answer should be compact. 0.62. What is the ratio of the Value added (% of GDP) of 1960 in Pakistan to that in South Africa?
Offer a very short reply. 0.41. What is the ratio of the Value added (% of GDP) in 1961 in Pakistan to that in South Africa?
Offer a very short reply. 0.44. What is the ratio of the Value added (% of GDP) in 1962 in Pakistan to that in South Africa?
Give a very brief answer. 0.47. What is the ratio of the Value added (% of GDP) of 1963 in Pakistan to that in South Africa?
Offer a very short reply. 0.52. What is the ratio of the Value added (% of GDP) in 1960 in Pakistan to that in Sri Lanka?
Keep it short and to the point. 0.76. What is the ratio of the Value added (% of GDP) in 1961 in Pakistan to that in Sri Lanka?
Offer a very short reply. 0.83. What is the ratio of the Value added (% of GDP) in 1962 in Pakistan to that in Sri Lanka?
Your response must be concise. 0.86. What is the ratio of the Value added (% of GDP) of 1963 in Pakistan to that in Sri Lanka?
Keep it short and to the point. 0.96. What is the ratio of the Value added (% of GDP) in 1960 in Philippines to that in South Africa?
Keep it short and to the point. 0.83. What is the ratio of the Value added (% of GDP) of 1961 in Philippines to that in South Africa?
Provide a short and direct response. 0.83. What is the ratio of the Value added (% of GDP) in 1962 in Philippines to that in South Africa?
Ensure brevity in your answer.  0.82. What is the ratio of the Value added (% of GDP) of 1963 in Philippines to that in South Africa?
Give a very brief answer. 0.83. What is the ratio of the Value added (% of GDP) in 1960 in Philippines to that in Sri Lanka?
Keep it short and to the point. 1.53. What is the ratio of the Value added (% of GDP) of 1961 in Philippines to that in Sri Lanka?
Your answer should be very brief. 1.56. What is the ratio of the Value added (% of GDP) in 1962 in Philippines to that in Sri Lanka?
Make the answer very short. 1.5. What is the ratio of the Value added (% of GDP) in 1963 in Philippines to that in Sri Lanka?
Ensure brevity in your answer.  1.55. What is the ratio of the Value added (% of GDP) in 1960 in South Africa to that in Sri Lanka?
Offer a very short reply. 1.85. What is the ratio of the Value added (% of GDP) in 1961 in South Africa to that in Sri Lanka?
Provide a short and direct response. 1.88. What is the ratio of the Value added (% of GDP) in 1962 in South Africa to that in Sri Lanka?
Make the answer very short. 1.83. What is the ratio of the Value added (% of GDP) in 1963 in South Africa to that in Sri Lanka?
Offer a terse response. 1.87. What is the difference between the highest and the second highest Value added (% of GDP) in 1960?
Keep it short and to the point. 6.55. What is the difference between the highest and the second highest Value added (% of GDP) of 1961?
Offer a terse response. 6.31. What is the difference between the highest and the second highest Value added (% of GDP) in 1962?
Keep it short and to the point. 6.86. What is the difference between the highest and the second highest Value added (% of GDP) of 1963?
Provide a succinct answer. 6.44. What is the difference between the highest and the lowest Value added (% of GDP) in 1960?
Offer a very short reply. 33.93. What is the difference between the highest and the lowest Value added (% of GDP) in 1961?
Provide a short and direct response. 34.51. What is the difference between the highest and the lowest Value added (% of GDP) of 1962?
Provide a succinct answer. 34.42. What is the difference between the highest and the lowest Value added (% of GDP) in 1963?
Offer a terse response. 34.4. 